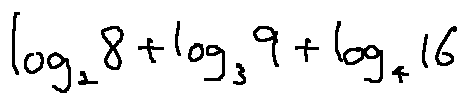Convert formula to latex. <formula><loc_0><loc_0><loc_500><loc_500>\log _ { 2 } 8 + \log _ { 3 } 9 + \log _ { 4 } 1 6</formula> 